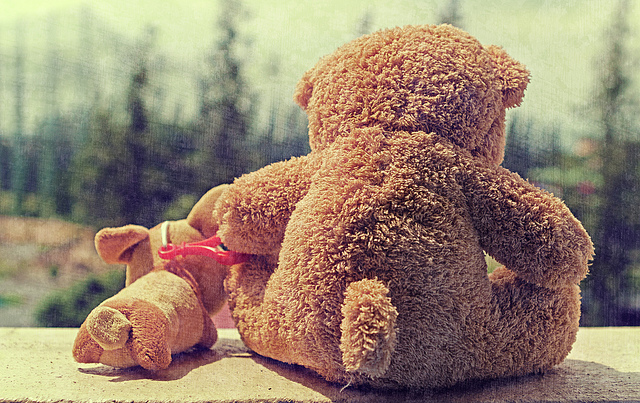How many teddy bears? There is one teddy bear prominently featured in the foreground, with its back turned, giving the impression of thoughtfulness. Additionally, there's a second, smaller teddy bear lying face-down in the background, creating a poignant scene that may evoke feelings of loneliness or contemplation. 